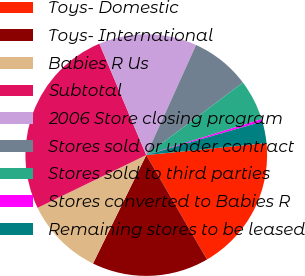<chart> <loc_0><loc_0><loc_500><loc_500><pie_chart><fcel>Toys- Domestic<fcel>Toys- International<fcel>Babies R Us<fcel>Subtotal<fcel>2006 Store closing program<fcel>Stores sold or under contract<fcel>Stores sold to third parties<fcel>Stores converted to Babies R<fcel>Remaining stores to be leased<nl><fcel>18.2%<fcel>15.65%<fcel>10.54%<fcel>25.86%<fcel>13.1%<fcel>7.99%<fcel>5.44%<fcel>0.33%<fcel>2.89%<nl></chart> 